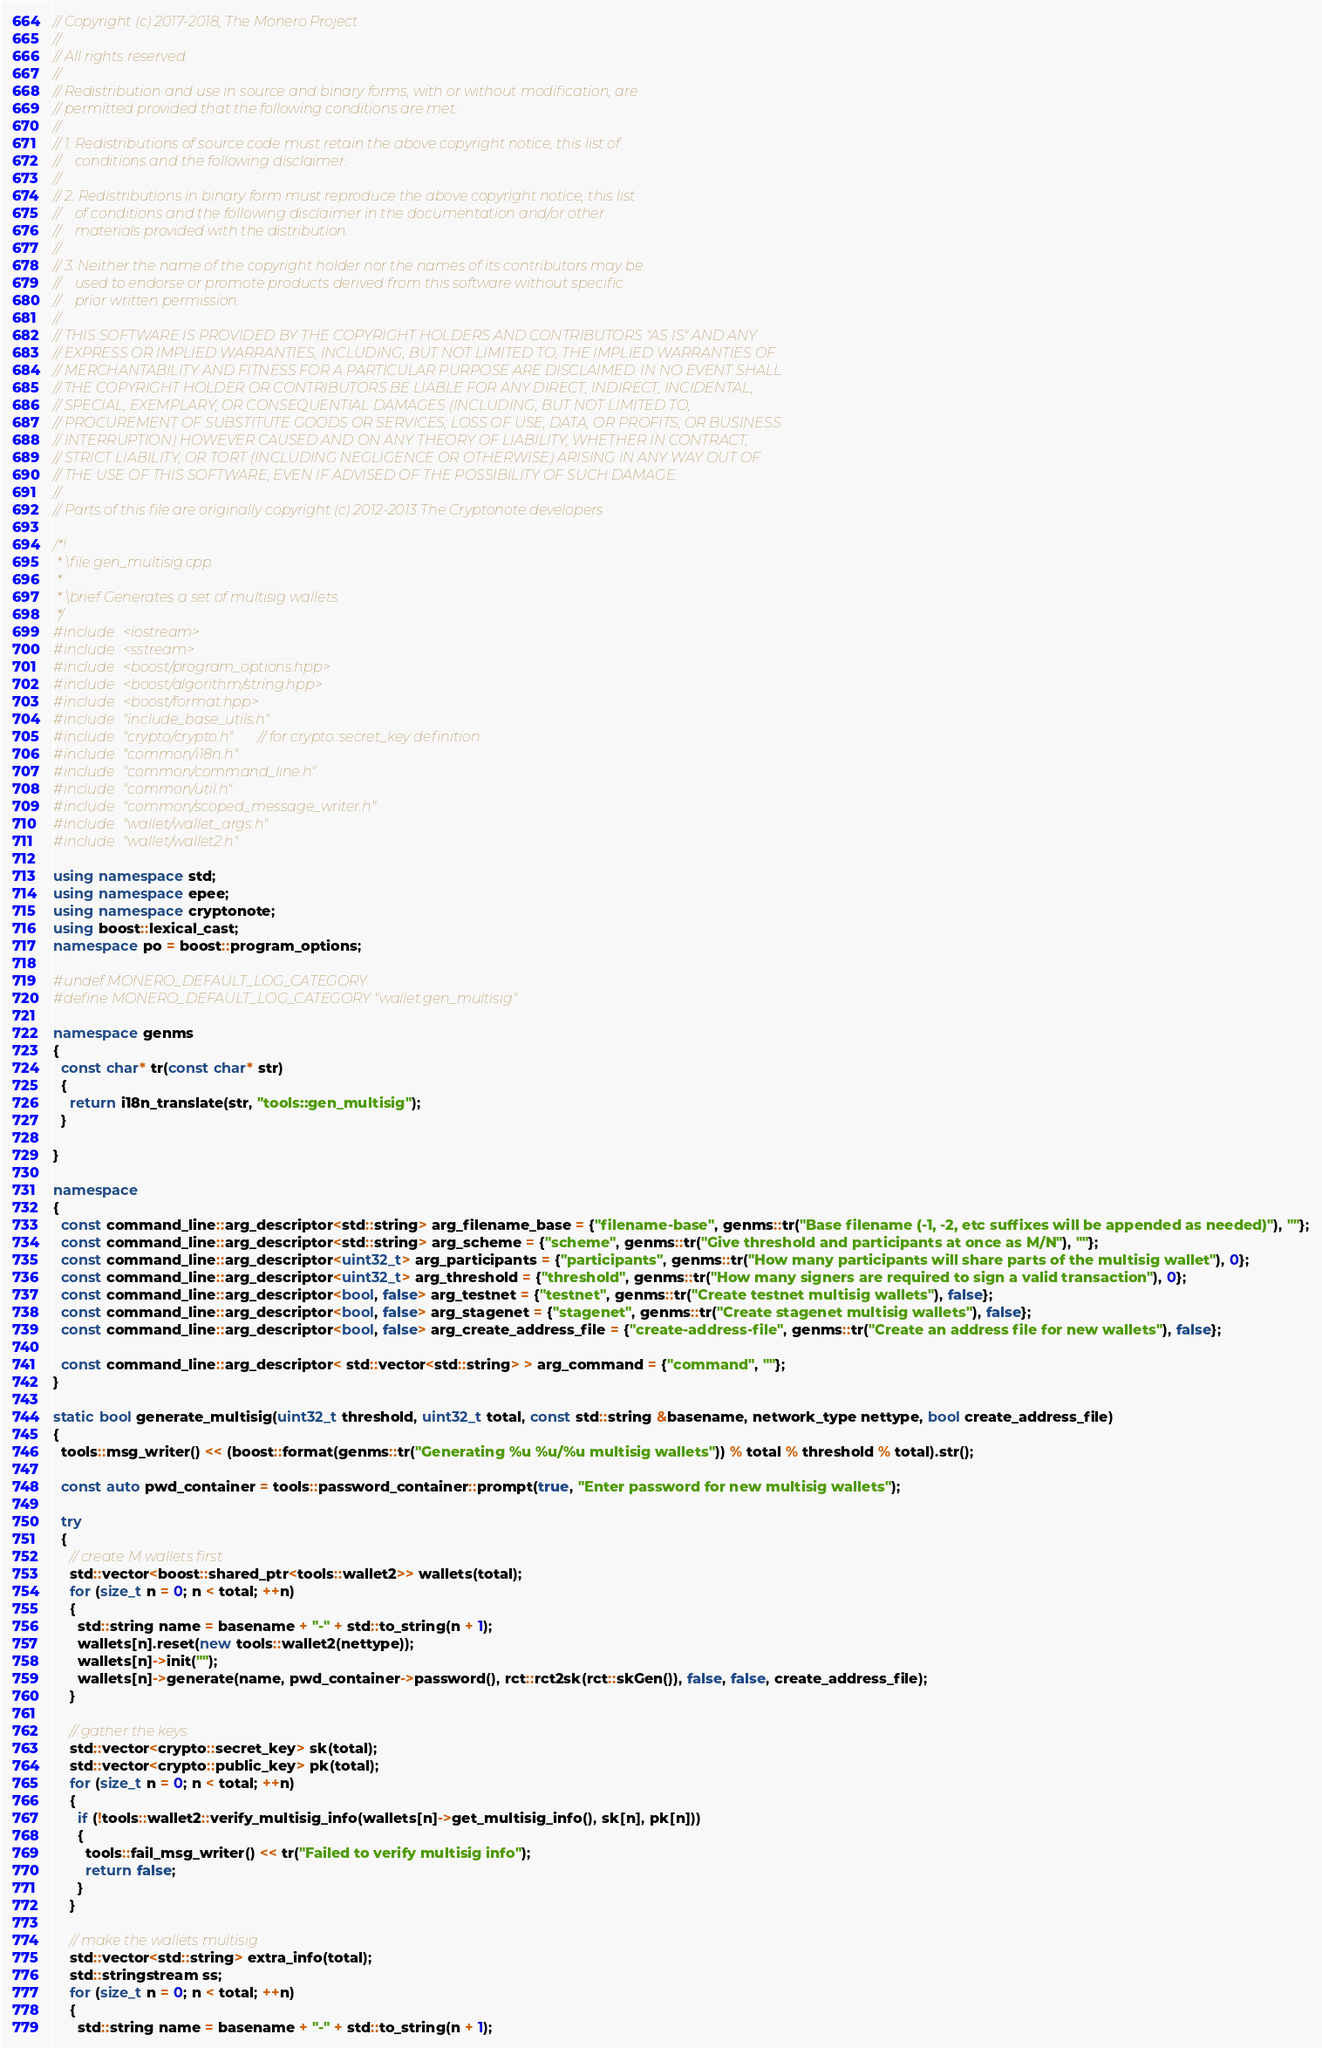Convert code to text. <code><loc_0><loc_0><loc_500><loc_500><_C++_>// Copyright (c) 2017-2018, The Monero Project
// 
// All rights reserved.
// 
// Redistribution and use in source and binary forms, with or without modification, are
// permitted provided that the following conditions are met:
// 
// 1. Redistributions of source code must retain the above copyright notice, this list of
//    conditions and the following disclaimer.
// 
// 2. Redistributions in binary form must reproduce the above copyright notice, this list
//    of conditions and the following disclaimer in the documentation and/or other
//    materials provided with the distribution.
// 
// 3. Neither the name of the copyright holder nor the names of its contributors may be
//    used to endorse or promote products derived from this software without specific
//    prior written permission.
// 
// THIS SOFTWARE IS PROVIDED BY THE COPYRIGHT HOLDERS AND CONTRIBUTORS "AS IS" AND ANY
// EXPRESS OR IMPLIED WARRANTIES, INCLUDING, BUT NOT LIMITED TO, THE IMPLIED WARRANTIES OF
// MERCHANTABILITY AND FITNESS FOR A PARTICULAR PURPOSE ARE DISCLAIMED. IN NO EVENT SHALL
// THE COPYRIGHT HOLDER OR CONTRIBUTORS BE LIABLE FOR ANY DIRECT, INDIRECT, INCIDENTAL,
// SPECIAL, EXEMPLARY, OR CONSEQUENTIAL DAMAGES (INCLUDING, BUT NOT LIMITED TO,
// PROCUREMENT OF SUBSTITUTE GOODS OR SERVICES; LOSS OF USE, DATA, OR PROFITS; OR BUSINESS
// INTERRUPTION) HOWEVER CAUSED AND ON ANY THEORY OF LIABILITY, WHETHER IN CONTRACT,
// STRICT LIABILITY, OR TORT (INCLUDING NEGLIGENCE OR OTHERWISE) ARISING IN ANY WAY OUT OF
// THE USE OF THIS SOFTWARE, EVEN IF ADVISED OF THE POSSIBILITY OF SUCH DAMAGE.
// 
// Parts of this file are originally copyright (c) 2012-2013 The Cryptonote developers

/*!
 * \file gen_multisig.cpp
 * 
 * \brief Generates a set of multisig wallets
 */
#include <iostream>
#include <sstream>
#include <boost/program_options.hpp>
#include <boost/algorithm/string.hpp>
#include <boost/format.hpp>
#include "include_base_utils.h"
#include "crypto/crypto.h"  // for crypto::secret_key definition
#include "common/i18n.h"
#include "common/command_line.h"
#include "common/util.h"
#include "common/scoped_message_writer.h"
#include "wallet/wallet_args.h"
#include "wallet/wallet2.h"

using namespace std;
using namespace epee;
using namespace cryptonote;
using boost::lexical_cast;
namespace po = boost::program_options;

#undef MONERO_DEFAULT_LOG_CATEGORY
#define MONERO_DEFAULT_LOG_CATEGORY "wallet.gen_multisig"

namespace genms
{
  const char* tr(const char* str)
  {
    return i18n_translate(str, "tools::gen_multisig");
  }

}

namespace
{
  const command_line::arg_descriptor<std::string> arg_filename_base = {"filename-base", genms::tr("Base filename (-1, -2, etc suffixes will be appended as needed)"), ""};
  const command_line::arg_descriptor<std::string> arg_scheme = {"scheme", genms::tr("Give threshold and participants at once as M/N"), ""};
  const command_line::arg_descriptor<uint32_t> arg_participants = {"participants", genms::tr("How many participants will share parts of the multisig wallet"), 0};
  const command_line::arg_descriptor<uint32_t> arg_threshold = {"threshold", genms::tr("How many signers are required to sign a valid transaction"), 0};
  const command_line::arg_descriptor<bool, false> arg_testnet = {"testnet", genms::tr("Create testnet multisig wallets"), false};
  const command_line::arg_descriptor<bool, false> arg_stagenet = {"stagenet", genms::tr("Create stagenet multisig wallets"), false};
  const command_line::arg_descriptor<bool, false> arg_create_address_file = {"create-address-file", genms::tr("Create an address file for new wallets"), false};

  const command_line::arg_descriptor< std::vector<std::string> > arg_command = {"command", ""};
}

static bool generate_multisig(uint32_t threshold, uint32_t total, const std::string &basename, network_type nettype, bool create_address_file)
{
  tools::msg_writer() << (boost::format(genms::tr("Generating %u %u/%u multisig wallets")) % total % threshold % total).str();

  const auto pwd_container = tools::password_container::prompt(true, "Enter password for new multisig wallets");

  try
  {
    // create M wallets first
    std::vector<boost::shared_ptr<tools::wallet2>> wallets(total);
    for (size_t n = 0; n < total; ++n)
    {
      std::string name = basename + "-" + std::to_string(n + 1);
      wallets[n].reset(new tools::wallet2(nettype));
      wallets[n]->init("");
      wallets[n]->generate(name, pwd_container->password(), rct::rct2sk(rct::skGen()), false, false, create_address_file);
    }

    // gather the keys
    std::vector<crypto::secret_key> sk(total);
    std::vector<crypto::public_key> pk(total);
    for (size_t n = 0; n < total; ++n)
    {
      if (!tools::wallet2::verify_multisig_info(wallets[n]->get_multisig_info(), sk[n], pk[n]))
      {
        tools::fail_msg_writer() << tr("Failed to verify multisig info");
        return false;
      }
    }

    // make the wallets multisig
    std::vector<std::string> extra_info(total);
    std::stringstream ss;
    for (size_t n = 0; n < total; ++n)
    {
      std::string name = basename + "-" + std::to_string(n + 1);</code> 